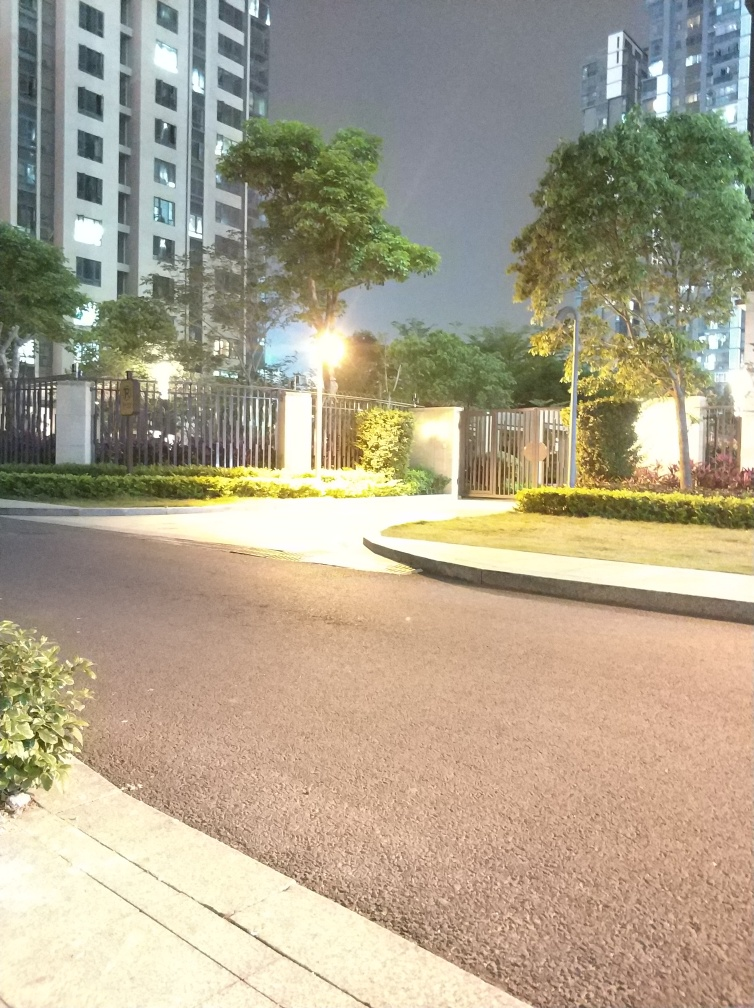Are there any elements in this image that might indicate the location? The image provides limited information about the specific location. The architecture of the building and the style of the street lamp might be indicative of certain regions, but there are no distinct landmarks or signage visible that could enable precise identification. Based on this image, what can you infer about the maintenance of this area? The area appears to be well-maintained, with manicured hedges, a clean sidewalk, and a well-lit environment. The presence of security fencing suggests a consideration for safety and privacy in this area. 